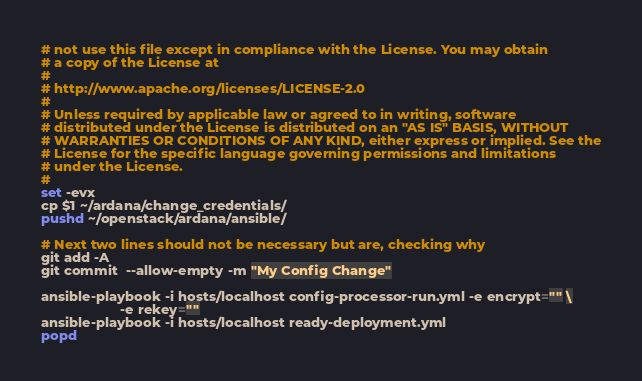<code> <loc_0><loc_0><loc_500><loc_500><_Bash_># not use this file except in compliance with the License. You may obtain
# a copy of the License at
#
# http://www.apache.org/licenses/LICENSE-2.0
#
# Unless required by applicable law or agreed to in writing, software
# distributed under the License is distributed on an "AS IS" BASIS, WITHOUT
# WARRANTIES OR CONDITIONS OF ANY KIND, either express or implied. See the
# License for the specific language governing permissions and limitations
# under the License.
#
set -evx
cp $1 ~/ardana/change_credentials/
pushd ~/openstack/ardana/ansible/

# Next two lines should not be necessary but are, checking why
git add -A
git commit  --allow-empty -m "My Config Change"

ansible-playbook -i hosts/localhost config-processor-run.yml -e encrypt="" \
                     -e rekey=""
ansible-playbook -i hosts/localhost ready-deployment.yml
popd
</code> 